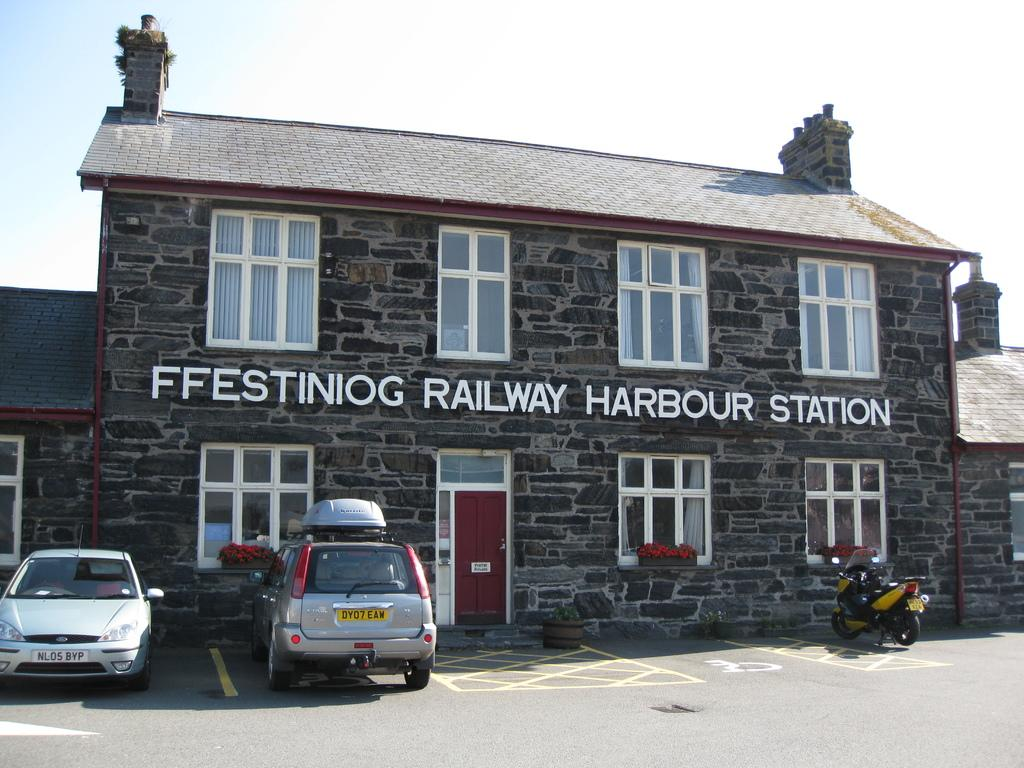What type of building is visible in the image? There is a house in the image. What vehicles are parked in front of the house? Two cars and a motorbike are parked in front of the house. Is there any text visible on the house? Yes, there is text written on the house. Where is the table located in the image? There is no table present in the image. How does the boot fit into the image? There is no boot present in the image. 